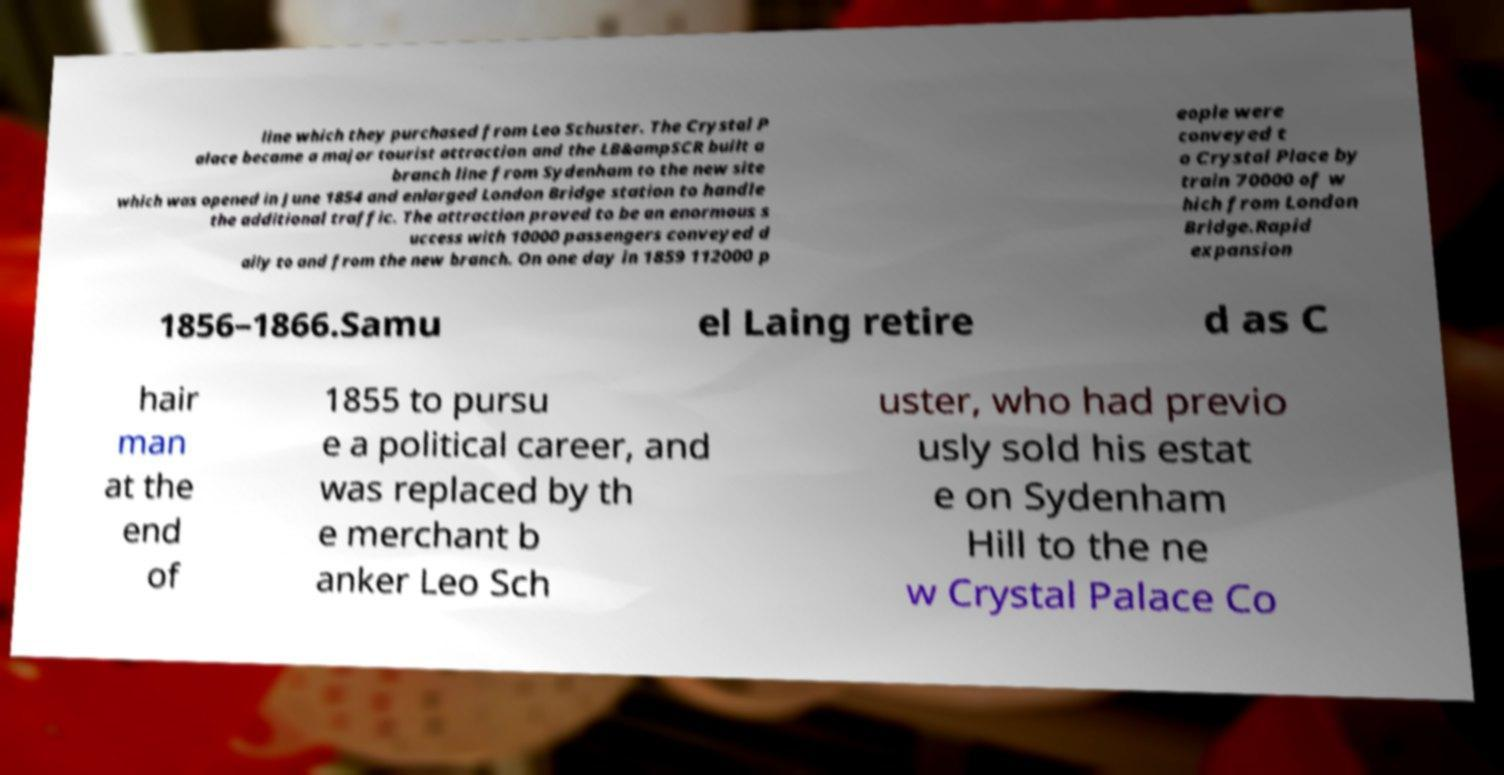Please read and relay the text visible in this image. What does it say? line which they purchased from Leo Schuster. The Crystal P alace became a major tourist attraction and the LB&ampSCR built a branch line from Sydenham to the new site which was opened in June 1854 and enlarged London Bridge station to handle the additional traffic. The attraction proved to be an enormous s uccess with 10000 passengers conveyed d aily to and from the new branch. On one day in 1859 112000 p eople were conveyed t o Crystal Place by train 70000 of w hich from London Bridge.Rapid expansion 1856–1866.Samu el Laing retire d as C hair man at the end of 1855 to pursu e a political career, and was replaced by th e merchant b anker Leo Sch uster, who had previo usly sold his estat e on Sydenham Hill to the ne w Crystal Palace Co 